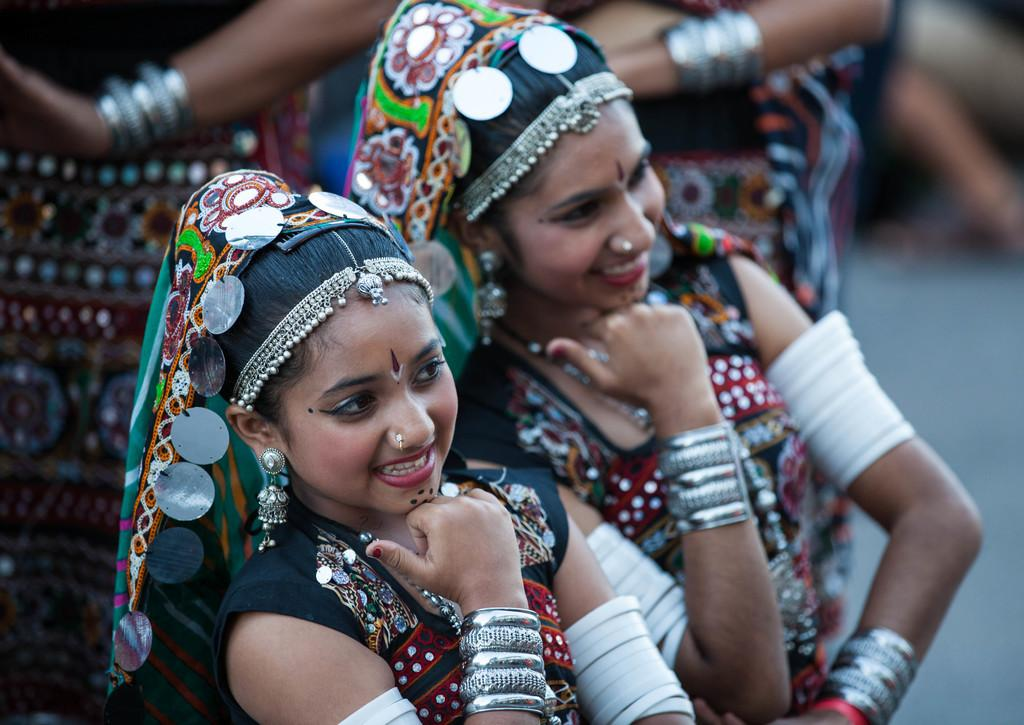How many people are present in the image? There are two people standing in the image. What are the people wearing? The people are wearing different costumes. What type of jewelry can be seen in the image? There are white and steel bangles and earrings visible in the image. Can you describe the background of the image? The background of the image is blurred. Are there any cobwebs visible in the image? There are no cobwebs present in the image. What type of plastic objects can be seen in the image? There are no plastic objects visible in the image. 